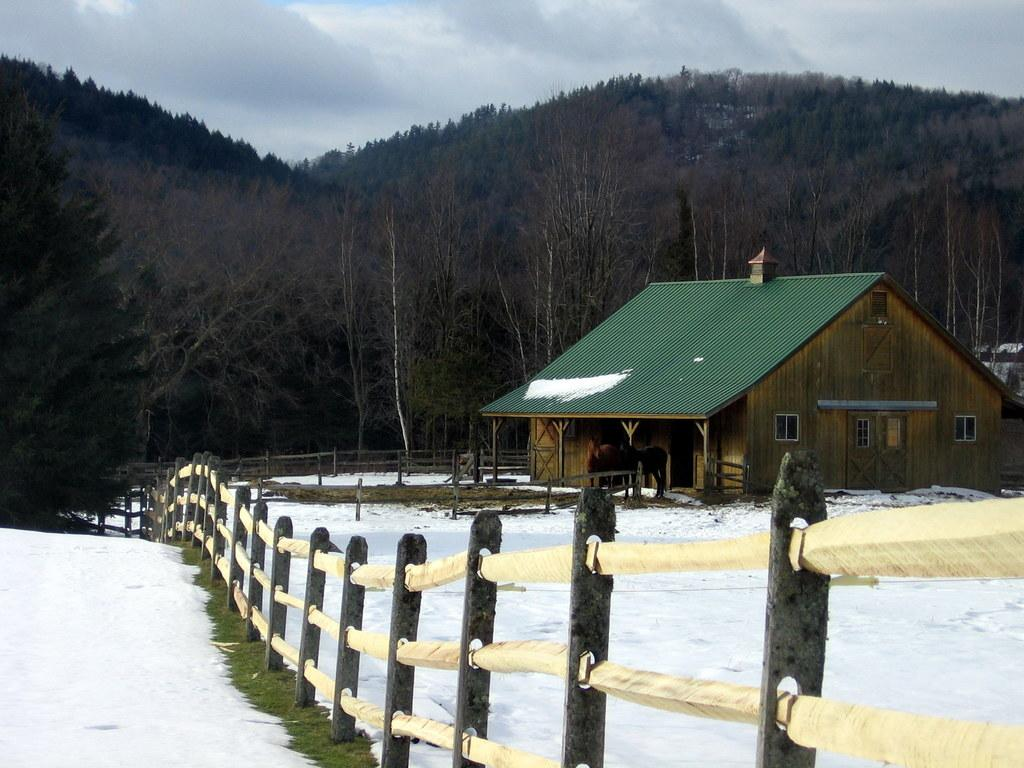What is the weather like in the image? The sky is cloudy in the image. What can be seen near the house? There is a fence and horses in front of the house. Can you describe the house in the image? The house has windows and a rooftop. What is visible in the background of the image? There are trees in the background of the image. How is the land covered in the image? The land is covered with snow. What type of quill is being used by the horse in the image? There are no quills or any writing instruments visible in the image. Can you tell me how many badges are pinned on the house in the image? There are no badges present on the house in the image. 